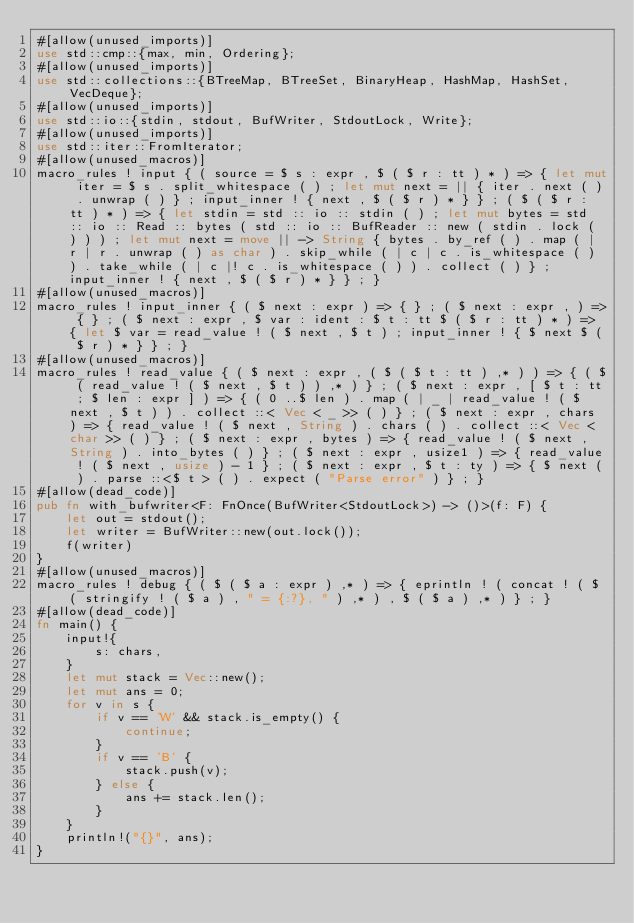<code> <loc_0><loc_0><loc_500><loc_500><_Rust_>#[allow(unused_imports)]
use std::cmp::{max, min, Ordering};
#[allow(unused_imports)]
use std::collections::{BTreeMap, BTreeSet, BinaryHeap, HashMap, HashSet, VecDeque};
#[allow(unused_imports)]
use std::io::{stdin, stdout, BufWriter, StdoutLock, Write};
#[allow(unused_imports)]
use std::iter::FromIterator;
#[allow(unused_macros)]
macro_rules ! input { ( source = $ s : expr , $ ( $ r : tt ) * ) => { let mut iter = $ s . split_whitespace ( ) ; let mut next = || { iter . next ( ) . unwrap ( ) } ; input_inner ! { next , $ ( $ r ) * } } ; ( $ ( $ r : tt ) * ) => { let stdin = std :: io :: stdin ( ) ; let mut bytes = std :: io :: Read :: bytes ( std :: io :: BufReader :: new ( stdin . lock ( ) ) ) ; let mut next = move || -> String { bytes . by_ref ( ) . map ( | r | r . unwrap ( ) as char ) . skip_while ( | c | c . is_whitespace ( ) ) . take_while ( | c |! c . is_whitespace ( ) ) . collect ( ) } ; input_inner ! { next , $ ( $ r ) * } } ; }
#[allow(unused_macros)]
macro_rules ! input_inner { ( $ next : expr ) => { } ; ( $ next : expr , ) => { } ; ( $ next : expr , $ var : ident : $ t : tt $ ( $ r : tt ) * ) => { let $ var = read_value ! ( $ next , $ t ) ; input_inner ! { $ next $ ( $ r ) * } } ; }
#[allow(unused_macros)]
macro_rules ! read_value { ( $ next : expr , ( $ ( $ t : tt ) ,* ) ) => { ( $ ( read_value ! ( $ next , $ t ) ) ,* ) } ; ( $ next : expr , [ $ t : tt ; $ len : expr ] ) => { ( 0 ..$ len ) . map ( | _ | read_value ! ( $ next , $ t ) ) . collect ::< Vec < _ >> ( ) } ; ( $ next : expr , chars ) => { read_value ! ( $ next , String ) . chars ( ) . collect ::< Vec < char >> ( ) } ; ( $ next : expr , bytes ) => { read_value ! ( $ next , String ) . into_bytes ( ) } ; ( $ next : expr , usize1 ) => { read_value ! ( $ next , usize ) - 1 } ; ( $ next : expr , $ t : ty ) => { $ next ( ) . parse ::<$ t > ( ) . expect ( "Parse error" ) } ; }
#[allow(dead_code)]
pub fn with_bufwriter<F: FnOnce(BufWriter<StdoutLock>) -> ()>(f: F) {
    let out = stdout();
    let writer = BufWriter::new(out.lock());
    f(writer)
}
#[allow(unused_macros)]
macro_rules ! debug { ( $ ( $ a : expr ) ,* ) => { eprintln ! ( concat ! ( $ ( stringify ! ( $ a ) , " = {:?}, " ) ,* ) , $ ( $ a ) ,* ) } ; }
#[allow(dead_code)]
fn main() {
    input!{
        s: chars,
    }
    let mut stack = Vec::new();
    let mut ans = 0;
    for v in s {
        if v == 'W' && stack.is_empty() {
            continue;
        }
        if v == 'B' {
            stack.push(v);
        } else {
            ans += stack.len();
        }
    }
    println!("{}", ans);
}</code> 